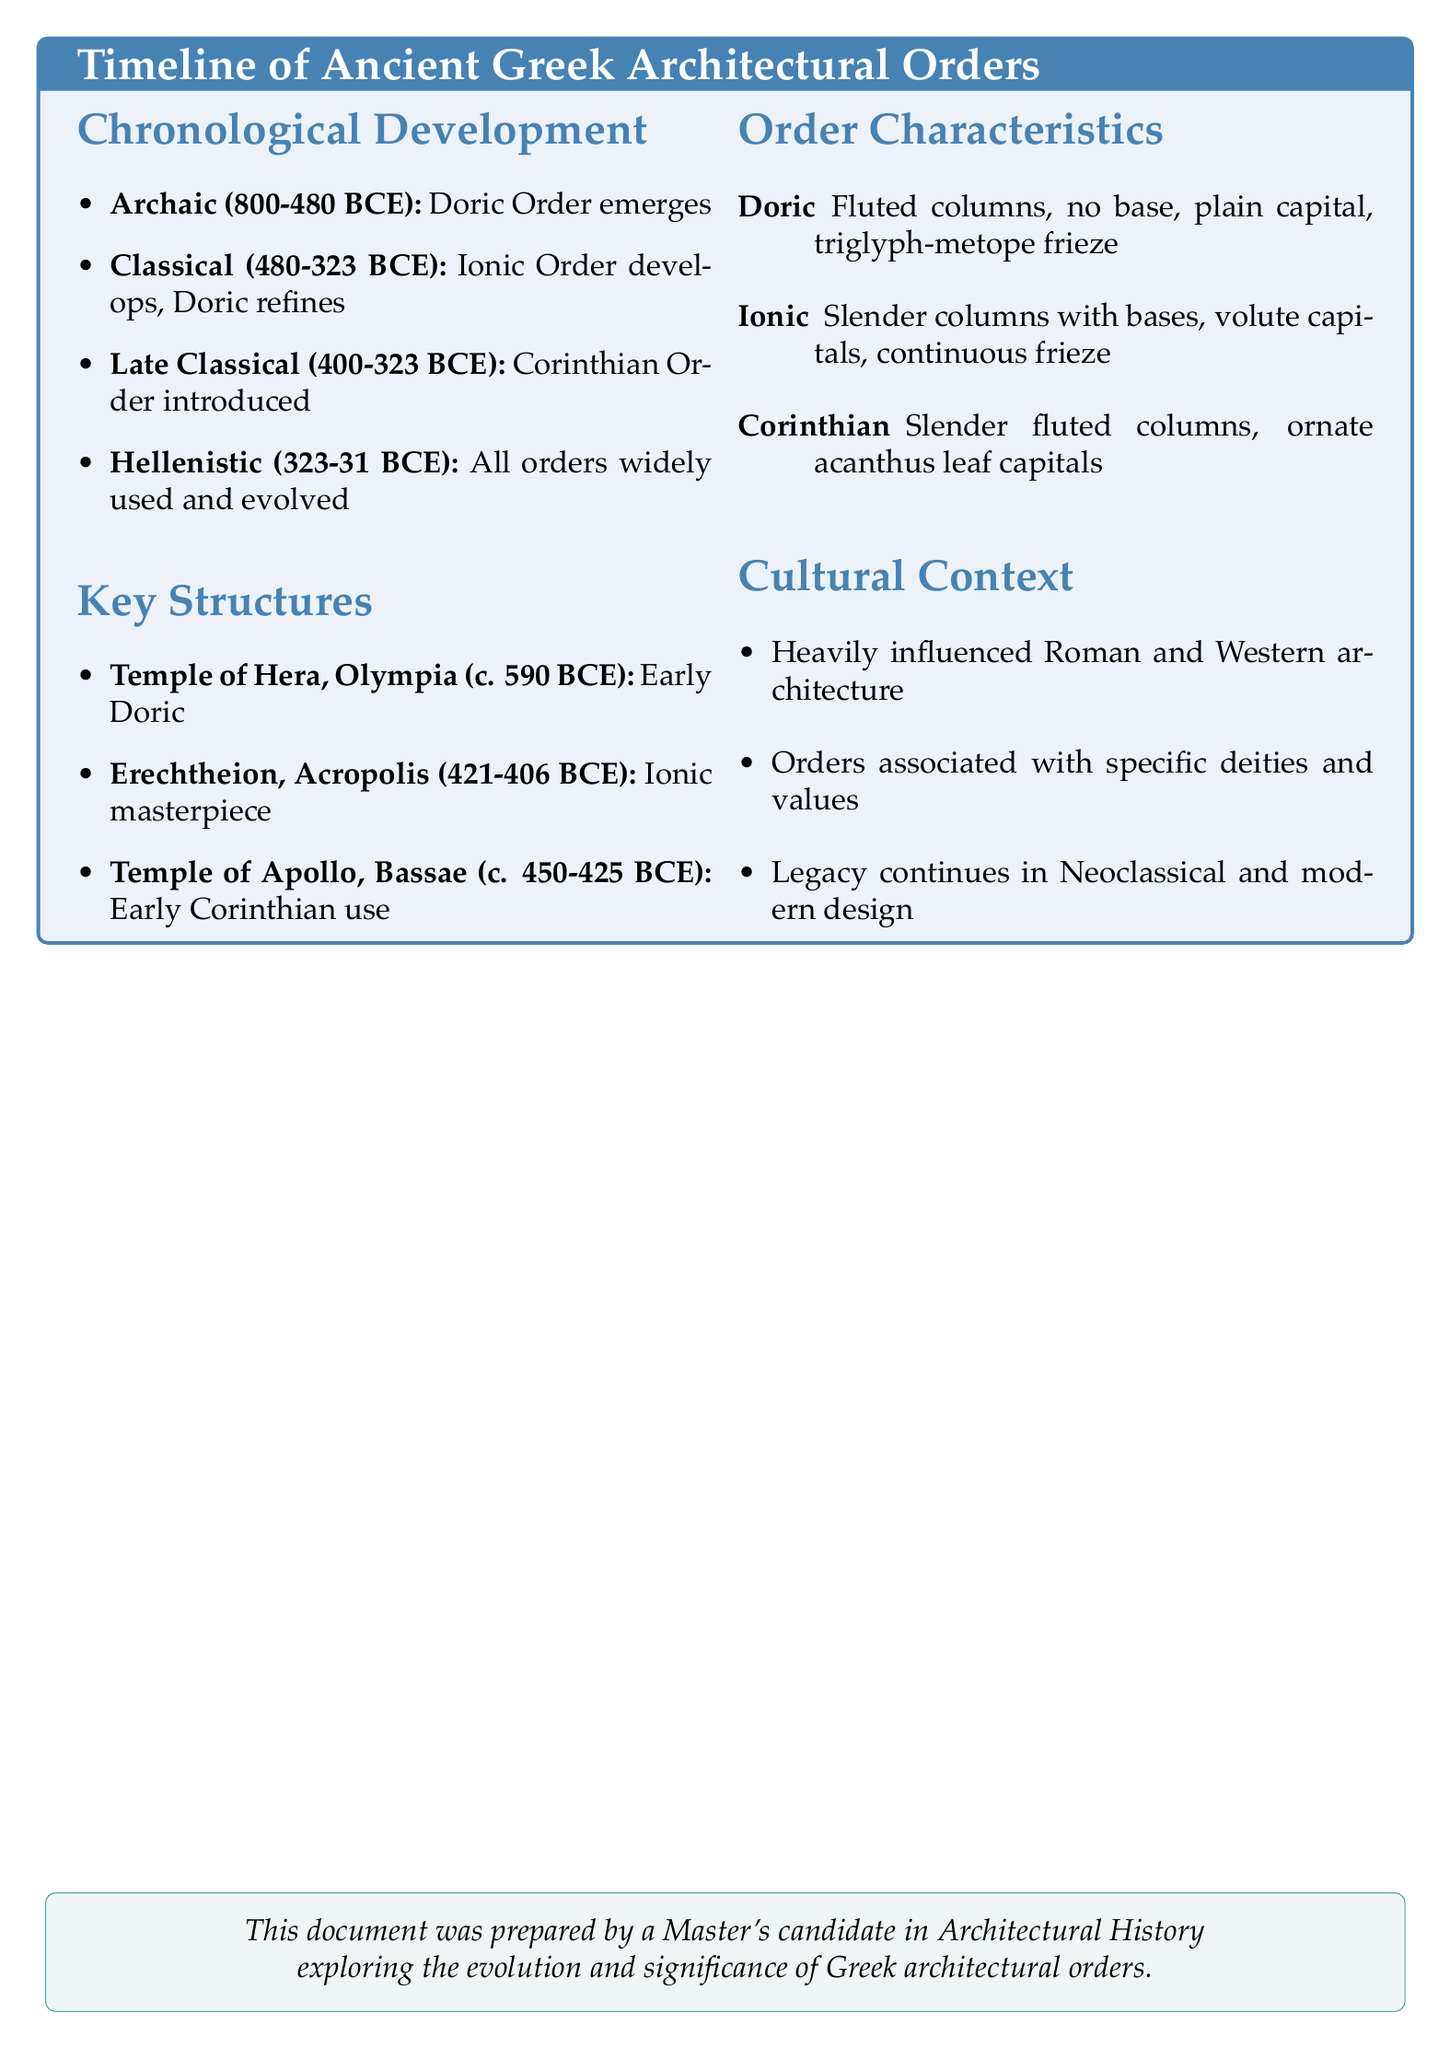What architectural order was developed first? The first standardized architectural order noted in the document is the Doric Order, which emerged during the Archaic Period.
Answer: Doric Order Which structure is an exemplary use of the Ionic order? The document specifies the Erechtheion on the Acropolis as an exemplary structure that features the Ionic architectural order.
Answer: Erechtheion In what period was the Corinthian Order introduced? The document states that the Corinthian Order was introduced during the Late Classical Period (400-323 BCE).
Answer: Late Classical Period What is a characteristic feature of Doric columns? According to the document, Doric columns are described as having fluted columns without bases and a plain capital.
Answer: Fluted columns without bases Which key structure dates to around 450-425 BCE? The document highlights the Temple of Apollo Epicurius at Bassae as a key structure that dates to approximately 450-425 BCE.
Answer: Temple of Apollo Epicurius at Bassae How did Greek architectural orders influence later styles? The document notes that Greek architectural orders heavily influenced Roman and later Western architecture.
Answer: Heavily influenced Roman and Western architecture What time frame corresponds to the Archaic Period? The Archaic Period is defined in the document as lasting from 800 to 480 BCE.
Answer: 800-480 BCE What is a distinctive feature of the Corinthian order? The document details that a distinctive feature of the Corinthian order is ornate capitals with acanthus leaves.
Answer: Ornate capitals with acanthus leaves 